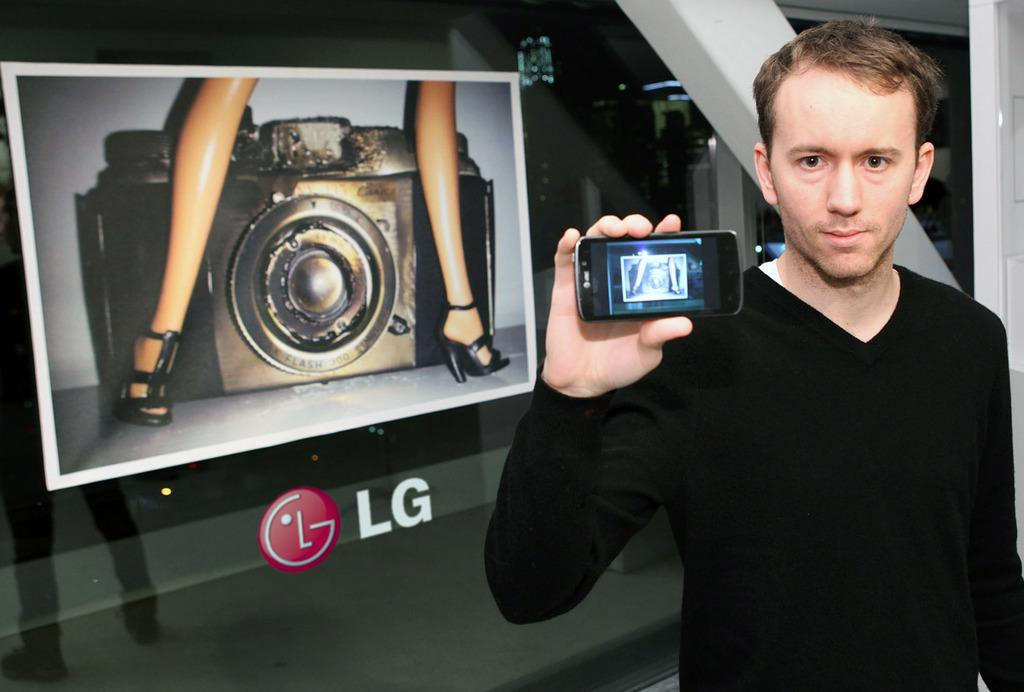What is the man holding in his hand in the image? The man is holding a mobile phone in his hand. What is the man wearing in the image? The man is wearing a black T-shirt. What can be seen in the image besides the man and his mobile phone? There is a photo with a camera in the image, and the photo contains a woman's legs. What company logo is visible in the image? The company logo (LG) is visible on the glass behind the man. Can you see a mountain in the image? No, there is no mountain present in the image. What is the man doing with his tongue in the image? There is no indication of the man using his tongue in the image. 